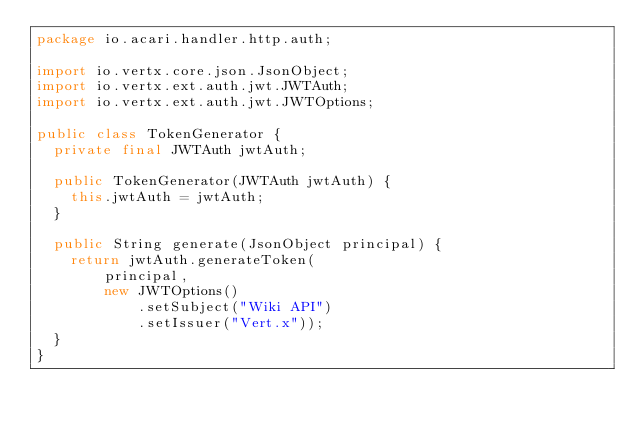Convert code to text. <code><loc_0><loc_0><loc_500><loc_500><_Java_>package io.acari.handler.http.auth;

import io.vertx.core.json.JsonObject;
import io.vertx.ext.auth.jwt.JWTAuth;
import io.vertx.ext.auth.jwt.JWTOptions;

public class TokenGenerator {
  private final JWTAuth jwtAuth;

  public TokenGenerator(JWTAuth jwtAuth) {
    this.jwtAuth = jwtAuth;
  }

  public String generate(JsonObject principal) {
    return jwtAuth.generateToken(
        principal,
        new JWTOptions()
            .setSubject("Wiki API")
            .setIssuer("Vert.x"));
  }
}
</code> 